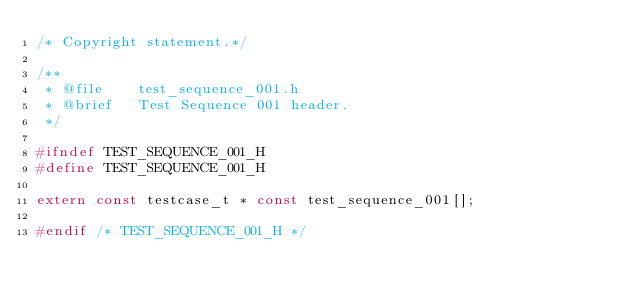Convert code to text. <code><loc_0><loc_0><loc_500><loc_500><_C_>/* Copyright statement.*/

/**
 * @file    test_sequence_001.h
 * @brief   Test Sequence 001 header.
 */

#ifndef TEST_SEQUENCE_001_H
#define TEST_SEQUENCE_001_H

extern const testcase_t * const test_sequence_001[];

#endif /* TEST_SEQUENCE_001_H */
</code> 